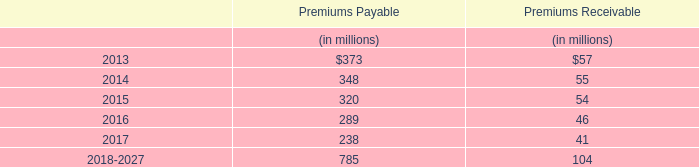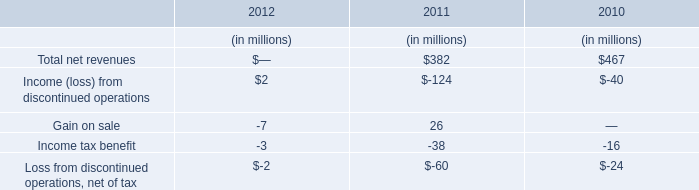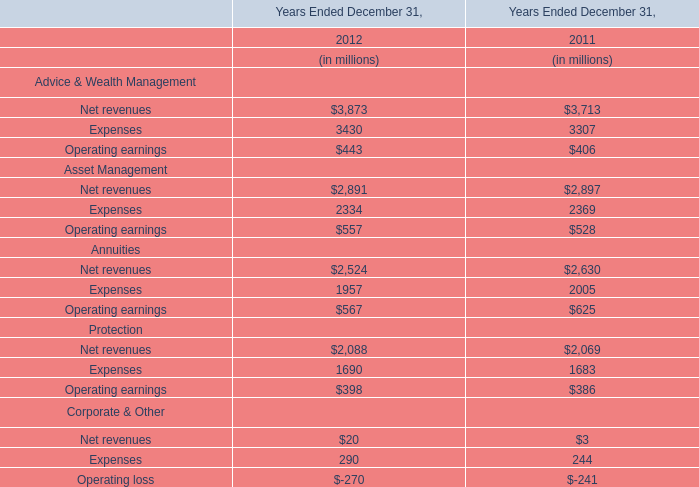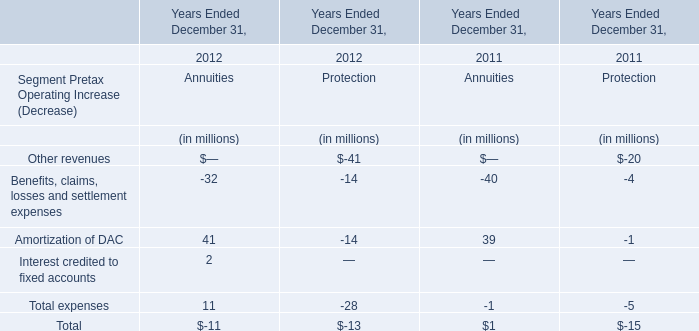What's the total amount of Annuities excluding those operating earnings greater than 600 in 2012? (in million) 
Computations: (2524 + 1957)
Answer: 4481.0. 